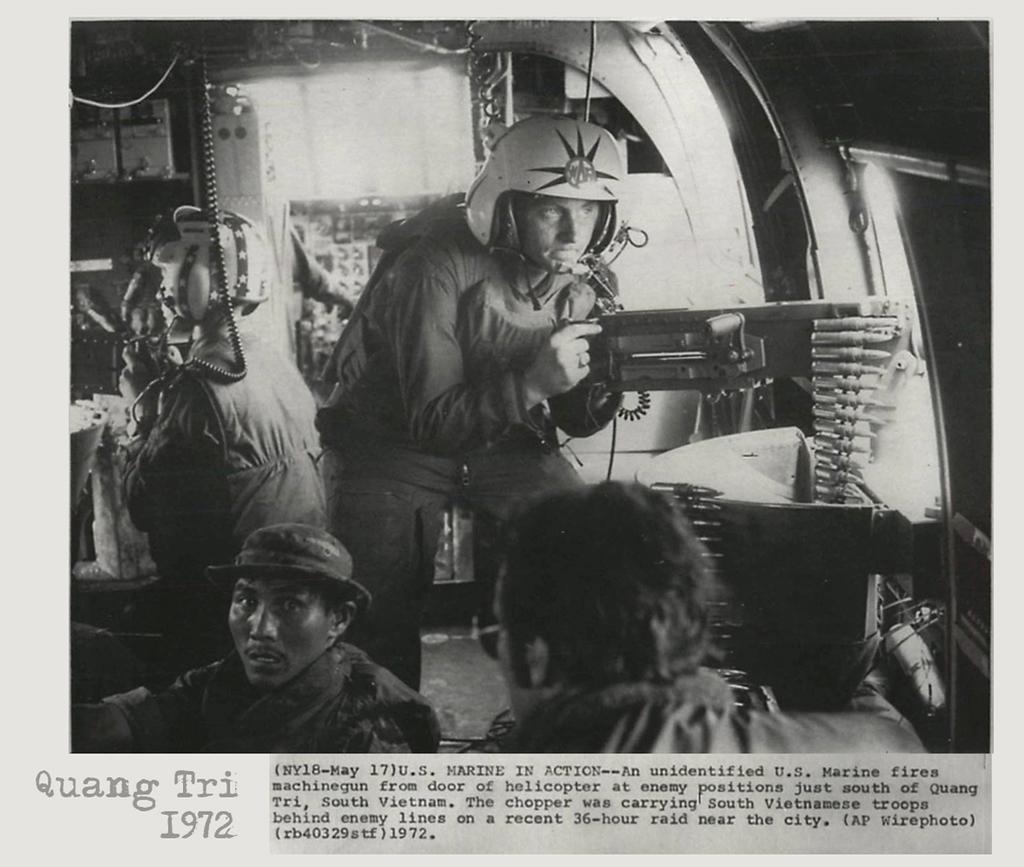In one or two sentences, can you explain what this image depicts? In this image there is an article. I can see people, helmets and objects. Something is written on the article. 